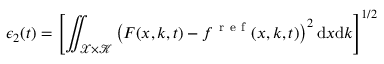<formula> <loc_0><loc_0><loc_500><loc_500>\epsilon _ { 2 } ( t ) = \left [ \iint _ { \mathcal { X } \times \mathcal { K } } \left ( F ( x , k , t ) - f ^ { r e f } ( x , k , t ) \right ) ^ { 2 } d x d k \right ] ^ { 1 / 2 }</formula> 